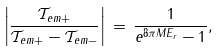<formula> <loc_0><loc_0><loc_500><loc_500>\left | \frac { \mathcal { T } _ { e m + } } { \mathcal { T } _ { e m + } - \mathcal { T } _ { e m - } } \right | \, = \, \frac { 1 } { e ^ { 8 \pi M E _ { r } } - 1 } ,</formula> 